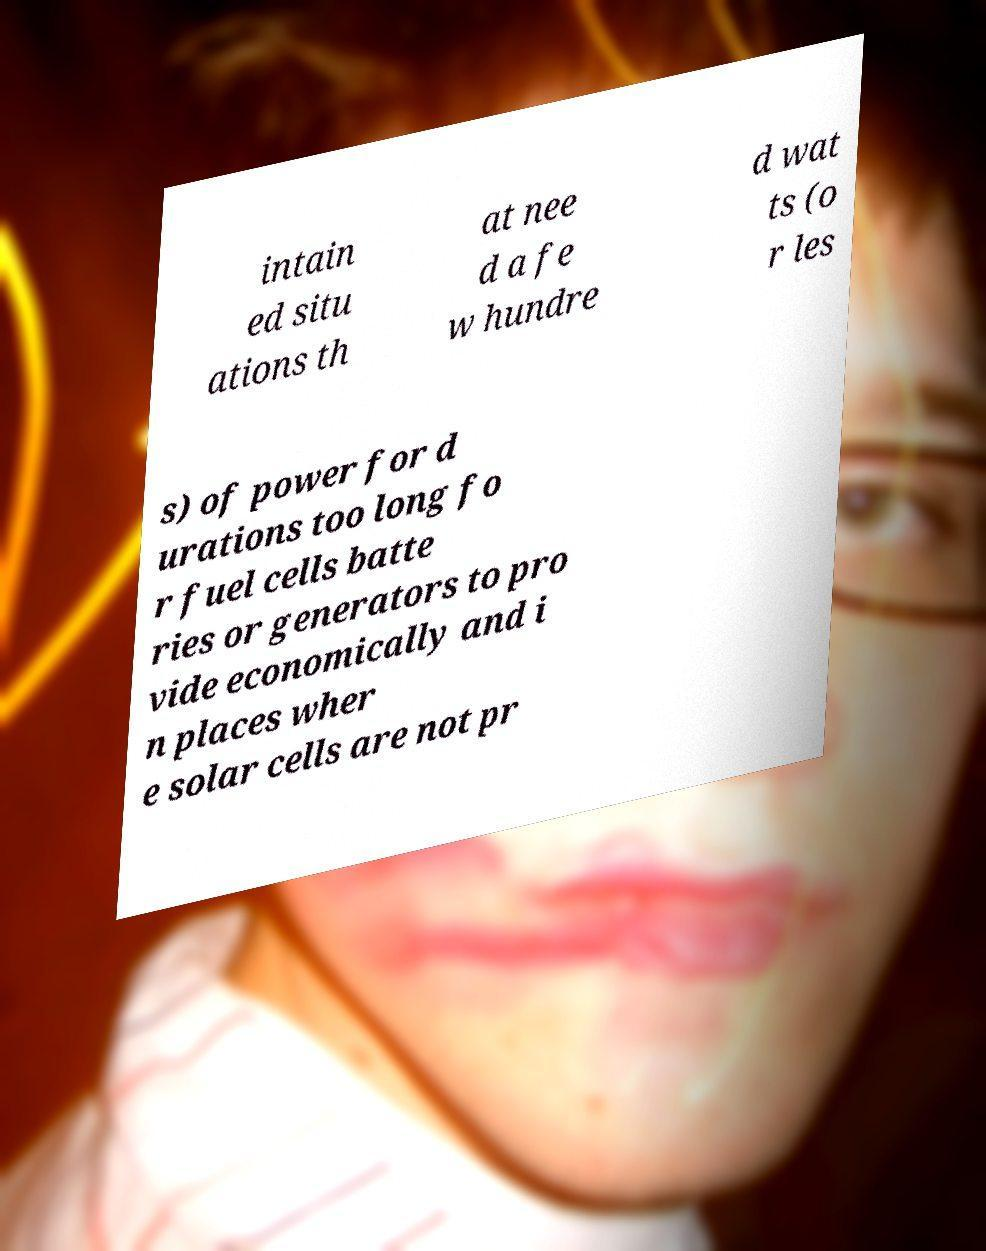What messages or text are displayed in this image? I need them in a readable, typed format. intain ed situ ations th at nee d a fe w hundre d wat ts (o r les s) of power for d urations too long fo r fuel cells batte ries or generators to pro vide economically and i n places wher e solar cells are not pr 